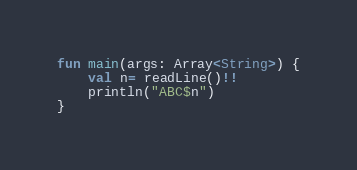Convert code to text. <code><loc_0><loc_0><loc_500><loc_500><_Kotlin_>fun main(args: Array<String>) {
    val n= readLine()!!
    println("ABC$n")
}</code> 